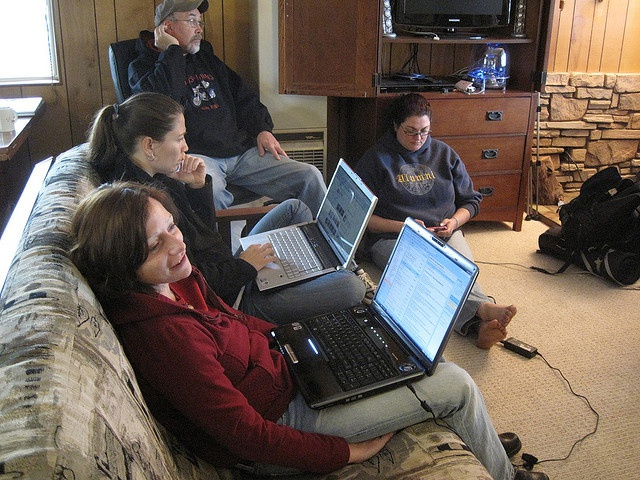Describe the objects in this image and their specific colors. I can see people in white, black, maroon, gray, and darkgray tones, couch in white, darkgray, and gray tones, people in white, black, and gray tones, laptop in white, black, lightblue, and gray tones, and people in white, black, gray, and darkgray tones in this image. 